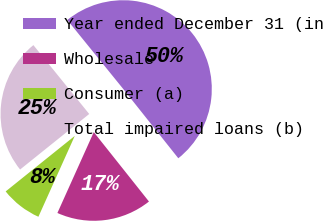Convert chart to OTSL. <chart><loc_0><loc_0><loc_500><loc_500><pie_chart><fcel>Year ended December 31 (in<fcel>Wholesale<fcel>Consumer (a)<fcel>Total impaired loans (b)<nl><fcel>50.15%<fcel>17.42%<fcel>7.5%<fcel>24.93%<nl></chart> 